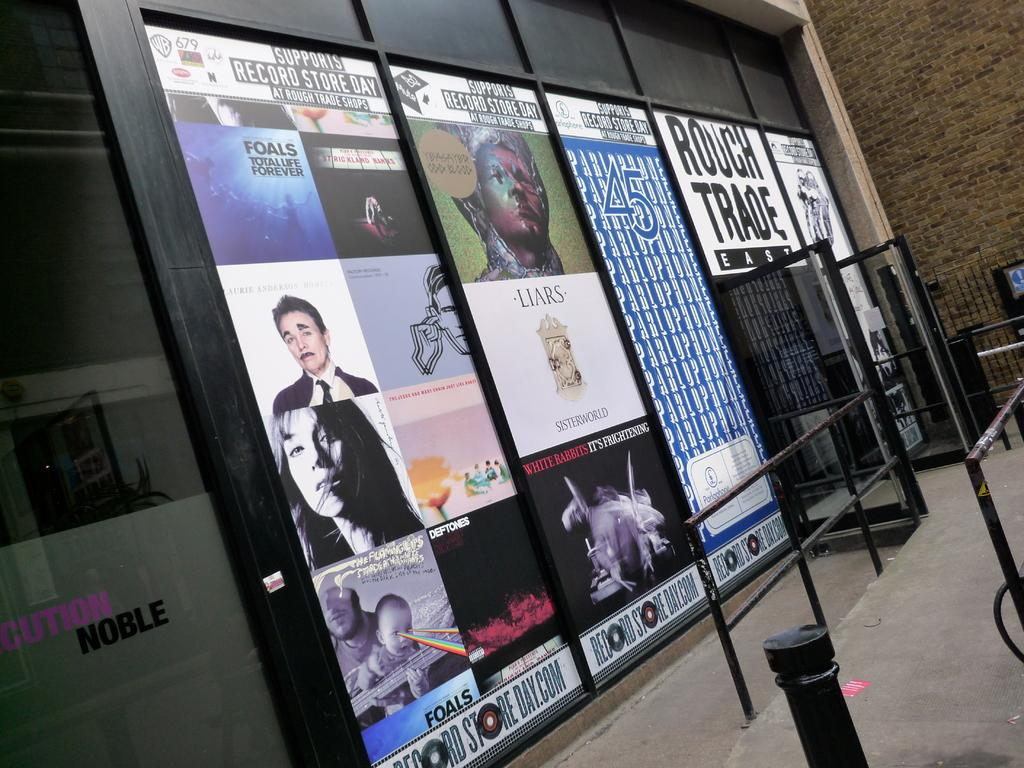What type of architectural feature can be seen in the image? There are iron grilles in the image. What is attached to the board in the image? There are posters on a board in the image. What type of opening is present in the image? There are doors in the image. What color is the ornament hanging from the ceiling in the image? There is no ornament hanging from the ceiling in the image. What type of prose is written on the posters in the image? The posters in the image do not contain any prose; they are visual displays. 